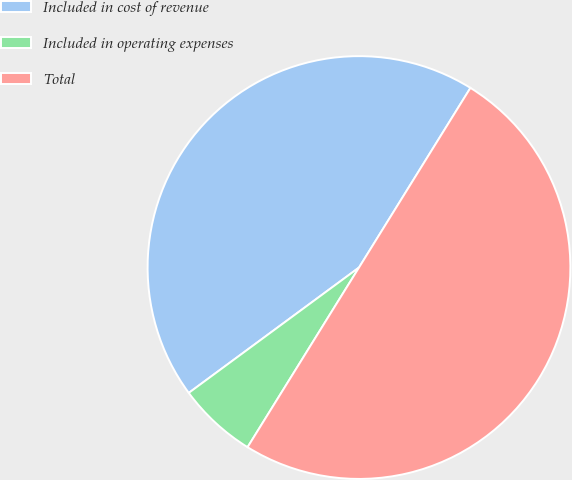Convert chart to OTSL. <chart><loc_0><loc_0><loc_500><loc_500><pie_chart><fcel>Included in cost of revenue<fcel>Included in operating expenses<fcel>Total<nl><fcel>43.94%<fcel>6.06%<fcel>50.0%<nl></chart> 